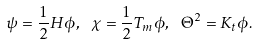<formula> <loc_0><loc_0><loc_500><loc_500>\psi = \frac { 1 } { 2 } H \phi , \ \chi = \frac { 1 } { 2 } T _ { m } \phi , \ \Theta ^ { 2 } = K _ { t } \phi .</formula> 